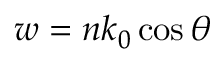<formula> <loc_0><loc_0><loc_500><loc_500>w = n k _ { 0 } \cos \theta</formula> 